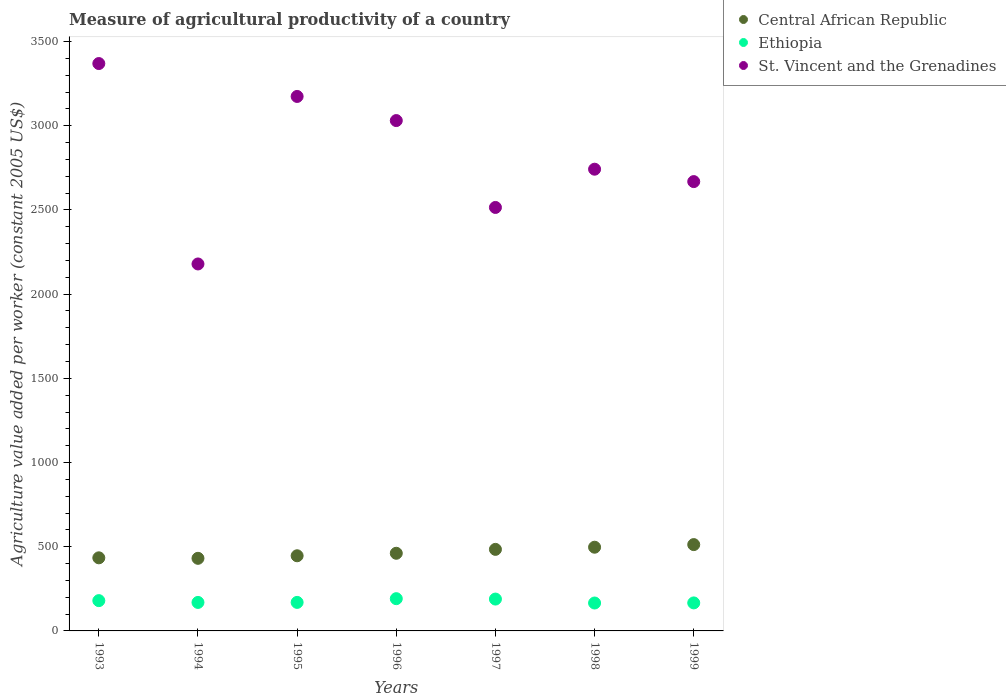What is the measure of agricultural productivity in Ethiopia in 1998?
Make the answer very short. 165.77. Across all years, what is the maximum measure of agricultural productivity in Ethiopia?
Offer a terse response. 191.52. Across all years, what is the minimum measure of agricultural productivity in Central African Republic?
Provide a succinct answer. 431.16. In which year was the measure of agricultural productivity in Ethiopia maximum?
Ensure brevity in your answer.  1996. What is the total measure of agricultural productivity in Central African Republic in the graph?
Provide a succinct answer. 3266.81. What is the difference between the measure of agricultural productivity in St. Vincent and the Grenadines in 1996 and that in 1998?
Offer a terse response. 288.8. What is the difference between the measure of agricultural productivity in Ethiopia in 1993 and the measure of agricultural productivity in St. Vincent and the Grenadines in 1995?
Keep it short and to the point. -2994.32. What is the average measure of agricultural productivity in Ethiopia per year?
Give a very brief answer. 175.9. In the year 1994, what is the difference between the measure of agricultural productivity in Ethiopia and measure of agricultural productivity in Central African Republic?
Keep it short and to the point. -261.98. What is the ratio of the measure of agricultural productivity in St. Vincent and the Grenadines in 1994 to that in 1997?
Your response must be concise. 0.87. What is the difference between the highest and the second highest measure of agricultural productivity in Central African Republic?
Your answer should be compact. 15.5. What is the difference between the highest and the lowest measure of agricultural productivity in St. Vincent and the Grenadines?
Give a very brief answer. 1190.19. Is it the case that in every year, the sum of the measure of agricultural productivity in St. Vincent and the Grenadines and measure of agricultural productivity in Ethiopia  is greater than the measure of agricultural productivity in Central African Republic?
Give a very brief answer. Yes. Is the measure of agricultural productivity in Central African Republic strictly less than the measure of agricultural productivity in St. Vincent and the Grenadines over the years?
Provide a succinct answer. Yes. How many dotlines are there?
Provide a succinct answer. 3. How many years are there in the graph?
Offer a very short reply. 7. What is the difference between two consecutive major ticks on the Y-axis?
Provide a succinct answer. 500. Are the values on the major ticks of Y-axis written in scientific E-notation?
Give a very brief answer. No. Does the graph contain grids?
Give a very brief answer. No. Where does the legend appear in the graph?
Provide a short and direct response. Top right. How are the legend labels stacked?
Your response must be concise. Vertical. What is the title of the graph?
Offer a terse response. Measure of agricultural productivity of a country. Does "Latin America(developing only)" appear as one of the legend labels in the graph?
Offer a very short reply. No. What is the label or title of the Y-axis?
Your response must be concise. Agriculture value added per worker (constant 2005 US$). What is the Agriculture value added per worker (constant 2005 US$) in Central African Republic in 1993?
Ensure brevity in your answer.  434.11. What is the Agriculture value added per worker (constant 2005 US$) in Ethiopia in 1993?
Provide a short and direct response. 179.89. What is the Agriculture value added per worker (constant 2005 US$) of St. Vincent and the Grenadines in 1993?
Your response must be concise. 3369.59. What is the Agriculture value added per worker (constant 2005 US$) in Central African Republic in 1994?
Your response must be concise. 431.16. What is the Agriculture value added per worker (constant 2005 US$) of Ethiopia in 1994?
Offer a terse response. 169.18. What is the Agriculture value added per worker (constant 2005 US$) of St. Vincent and the Grenadines in 1994?
Offer a terse response. 2179.39. What is the Agriculture value added per worker (constant 2005 US$) of Central African Republic in 1995?
Provide a succinct answer. 446.32. What is the Agriculture value added per worker (constant 2005 US$) in Ethiopia in 1995?
Provide a short and direct response. 169.39. What is the Agriculture value added per worker (constant 2005 US$) in St. Vincent and the Grenadines in 1995?
Offer a terse response. 3174.2. What is the Agriculture value added per worker (constant 2005 US$) in Central African Republic in 1996?
Your answer should be very brief. 461.15. What is the Agriculture value added per worker (constant 2005 US$) in Ethiopia in 1996?
Give a very brief answer. 191.52. What is the Agriculture value added per worker (constant 2005 US$) of St. Vincent and the Grenadines in 1996?
Make the answer very short. 3030.91. What is the Agriculture value added per worker (constant 2005 US$) of Central African Republic in 1997?
Your answer should be very brief. 484.31. What is the Agriculture value added per worker (constant 2005 US$) of Ethiopia in 1997?
Offer a terse response. 189.17. What is the Agriculture value added per worker (constant 2005 US$) of St. Vincent and the Grenadines in 1997?
Make the answer very short. 2514.94. What is the Agriculture value added per worker (constant 2005 US$) in Central African Republic in 1998?
Your answer should be very brief. 497.13. What is the Agriculture value added per worker (constant 2005 US$) in Ethiopia in 1998?
Ensure brevity in your answer.  165.77. What is the Agriculture value added per worker (constant 2005 US$) of St. Vincent and the Grenadines in 1998?
Provide a succinct answer. 2742.11. What is the Agriculture value added per worker (constant 2005 US$) of Central African Republic in 1999?
Provide a succinct answer. 512.63. What is the Agriculture value added per worker (constant 2005 US$) in Ethiopia in 1999?
Give a very brief answer. 166.37. What is the Agriculture value added per worker (constant 2005 US$) in St. Vincent and the Grenadines in 1999?
Provide a succinct answer. 2668.51. Across all years, what is the maximum Agriculture value added per worker (constant 2005 US$) in Central African Republic?
Provide a succinct answer. 512.63. Across all years, what is the maximum Agriculture value added per worker (constant 2005 US$) in Ethiopia?
Provide a short and direct response. 191.52. Across all years, what is the maximum Agriculture value added per worker (constant 2005 US$) of St. Vincent and the Grenadines?
Keep it short and to the point. 3369.59. Across all years, what is the minimum Agriculture value added per worker (constant 2005 US$) of Central African Republic?
Offer a terse response. 431.16. Across all years, what is the minimum Agriculture value added per worker (constant 2005 US$) of Ethiopia?
Your response must be concise. 165.77. Across all years, what is the minimum Agriculture value added per worker (constant 2005 US$) in St. Vincent and the Grenadines?
Give a very brief answer. 2179.39. What is the total Agriculture value added per worker (constant 2005 US$) in Central African Republic in the graph?
Provide a short and direct response. 3266.81. What is the total Agriculture value added per worker (constant 2005 US$) in Ethiopia in the graph?
Provide a short and direct response. 1231.28. What is the total Agriculture value added per worker (constant 2005 US$) in St. Vincent and the Grenadines in the graph?
Keep it short and to the point. 1.97e+04. What is the difference between the Agriculture value added per worker (constant 2005 US$) in Central African Republic in 1993 and that in 1994?
Your answer should be compact. 2.95. What is the difference between the Agriculture value added per worker (constant 2005 US$) of Ethiopia in 1993 and that in 1994?
Make the answer very short. 10.7. What is the difference between the Agriculture value added per worker (constant 2005 US$) of St. Vincent and the Grenadines in 1993 and that in 1994?
Provide a succinct answer. 1190.19. What is the difference between the Agriculture value added per worker (constant 2005 US$) in Central African Republic in 1993 and that in 1995?
Keep it short and to the point. -12.2. What is the difference between the Agriculture value added per worker (constant 2005 US$) of Ethiopia in 1993 and that in 1995?
Ensure brevity in your answer.  10.5. What is the difference between the Agriculture value added per worker (constant 2005 US$) in St. Vincent and the Grenadines in 1993 and that in 1995?
Your answer should be very brief. 195.38. What is the difference between the Agriculture value added per worker (constant 2005 US$) of Central African Republic in 1993 and that in 1996?
Keep it short and to the point. -27.04. What is the difference between the Agriculture value added per worker (constant 2005 US$) in Ethiopia in 1993 and that in 1996?
Your answer should be very brief. -11.64. What is the difference between the Agriculture value added per worker (constant 2005 US$) in St. Vincent and the Grenadines in 1993 and that in 1996?
Offer a very short reply. 338.68. What is the difference between the Agriculture value added per worker (constant 2005 US$) in Central African Republic in 1993 and that in 1997?
Your response must be concise. -50.19. What is the difference between the Agriculture value added per worker (constant 2005 US$) of Ethiopia in 1993 and that in 1997?
Your answer should be compact. -9.29. What is the difference between the Agriculture value added per worker (constant 2005 US$) of St. Vincent and the Grenadines in 1993 and that in 1997?
Give a very brief answer. 854.64. What is the difference between the Agriculture value added per worker (constant 2005 US$) in Central African Republic in 1993 and that in 1998?
Provide a succinct answer. -63.01. What is the difference between the Agriculture value added per worker (constant 2005 US$) of Ethiopia in 1993 and that in 1998?
Ensure brevity in your answer.  14.12. What is the difference between the Agriculture value added per worker (constant 2005 US$) in St. Vincent and the Grenadines in 1993 and that in 1998?
Ensure brevity in your answer.  627.48. What is the difference between the Agriculture value added per worker (constant 2005 US$) of Central African Republic in 1993 and that in 1999?
Offer a very short reply. -78.52. What is the difference between the Agriculture value added per worker (constant 2005 US$) of Ethiopia in 1993 and that in 1999?
Make the answer very short. 13.52. What is the difference between the Agriculture value added per worker (constant 2005 US$) of St. Vincent and the Grenadines in 1993 and that in 1999?
Keep it short and to the point. 701.08. What is the difference between the Agriculture value added per worker (constant 2005 US$) of Central African Republic in 1994 and that in 1995?
Make the answer very short. -15.15. What is the difference between the Agriculture value added per worker (constant 2005 US$) in Ethiopia in 1994 and that in 1995?
Your answer should be compact. -0.21. What is the difference between the Agriculture value added per worker (constant 2005 US$) of St. Vincent and the Grenadines in 1994 and that in 1995?
Your answer should be very brief. -994.81. What is the difference between the Agriculture value added per worker (constant 2005 US$) of Central African Republic in 1994 and that in 1996?
Your answer should be very brief. -29.99. What is the difference between the Agriculture value added per worker (constant 2005 US$) in Ethiopia in 1994 and that in 1996?
Provide a short and direct response. -22.34. What is the difference between the Agriculture value added per worker (constant 2005 US$) of St. Vincent and the Grenadines in 1994 and that in 1996?
Provide a short and direct response. -851.51. What is the difference between the Agriculture value added per worker (constant 2005 US$) in Central African Republic in 1994 and that in 1997?
Give a very brief answer. -53.15. What is the difference between the Agriculture value added per worker (constant 2005 US$) in Ethiopia in 1994 and that in 1997?
Your response must be concise. -19.99. What is the difference between the Agriculture value added per worker (constant 2005 US$) in St. Vincent and the Grenadines in 1994 and that in 1997?
Provide a succinct answer. -335.55. What is the difference between the Agriculture value added per worker (constant 2005 US$) in Central African Republic in 1994 and that in 1998?
Your response must be concise. -65.96. What is the difference between the Agriculture value added per worker (constant 2005 US$) in Ethiopia in 1994 and that in 1998?
Your response must be concise. 3.42. What is the difference between the Agriculture value added per worker (constant 2005 US$) in St. Vincent and the Grenadines in 1994 and that in 1998?
Your answer should be compact. -562.72. What is the difference between the Agriculture value added per worker (constant 2005 US$) in Central African Republic in 1994 and that in 1999?
Your response must be concise. -81.47. What is the difference between the Agriculture value added per worker (constant 2005 US$) in Ethiopia in 1994 and that in 1999?
Give a very brief answer. 2.82. What is the difference between the Agriculture value added per worker (constant 2005 US$) of St. Vincent and the Grenadines in 1994 and that in 1999?
Provide a succinct answer. -489.12. What is the difference between the Agriculture value added per worker (constant 2005 US$) of Central African Republic in 1995 and that in 1996?
Your answer should be very brief. -14.84. What is the difference between the Agriculture value added per worker (constant 2005 US$) in Ethiopia in 1995 and that in 1996?
Your answer should be compact. -22.13. What is the difference between the Agriculture value added per worker (constant 2005 US$) in St. Vincent and the Grenadines in 1995 and that in 1996?
Offer a terse response. 143.3. What is the difference between the Agriculture value added per worker (constant 2005 US$) in Central African Republic in 1995 and that in 1997?
Offer a very short reply. -37.99. What is the difference between the Agriculture value added per worker (constant 2005 US$) of Ethiopia in 1995 and that in 1997?
Your answer should be compact. -19.79. What is the difference between the Agriculture value added per worker (constant 2005 US$) of St. Vincent and the Grenadines in 1995 and that in 1997?
Offer a very short reply. 659.26. What is the difference between the Agriculture value added per worker (constant 2005 US$) in Central African Republic in 1995 and that in 1998?
Provide a short and direct response. -50.81. What is the difference between the Agriculture value added per worker (constant 2005 US$) in Ethiopia in 1995 and that in 1998?
Make the answer very short. 3.62. What is the difference between the Agriculture value added per worker (constant 2005 US$) in St. Vincent and the Grenadines in 1995 and that in 1998?
Your response must be concise. 432.09. What is the difference between the Agriculture value added per worker (constant 2005 US$) of Central African Republic in 1995 and that in 1999?
Give a very brief answer. -66.31. What is the difference between the Agriculture value added per worker (constant 2005 US$) of Ethiopia in 1995 and that in 1999?
Ensure brevity in your answer.  3.02. What is the difference between the Agriculture value added per worker (constant 2005 US$) in St. Vincent and the Grenadines in 1995 and that in 1999?
Provide a short and direct response. 505.69. What is the difference between the Agriculture value added per worker (constant 2005 US$) in Central African Republic in 1996 and that in 1997?
Offer a terse response. -23.15. What is the difference between the Agriculture value added per worker (constant 2005 US$) of Ethiopia in 1996 and that in 1997?
Your response must be concise. 2.35. What is the difference between the Agriculture value added per worker (constant 2005 US$) in St. Vincent and the Grenadines in 1996 and that in 1997?
Give a very brief answer. 515.96. What is the difference between the Agriculture value added per worker (constant 2005 US$) of Central African Republic in 1996 and that in 1998?
Offer a terse response. -35.97. What is the difference between the Agriculture value added per worker (constant 2005 US$) in Ethiopia in 1996 and that in 1998?
Offer a terse response. 25.76. What is the difference between the Agriculture value added per worker (constant 2005 US$) in St. Vincent and the Grenadines in 1996 and that in 1998?
Give a very brief answer. 288.8. What is the difference between the Agriculture value added per worker (constant 2005 US$) in Central African Republic in 1996 and that in 1999?
Provide a succinct answer. -51.47. What is the difference between the Agriculture value added per worker (constant 2005 US$) of Ethiopia in 1996 and that in 1999?
Provide a succinct answer. 25.16. What is the difference between the Agriculture value added per worker (constant 2005 US$) in St. Vincent and the Grenadines in 1996 and that in 1999?
Provide a short and direct response. 362.4. What is the difference between the Agriculture value added per worker (constant 2005 US$) in Central African Republic in 1997 and that in 1998?
Your answer should be very brief. -12.82. What is the difference between the Agriculture value added per worker (constant 2005 US$) of Ethiopia in 1997 and that in 1998?
Your answer should be very brief. 23.41. What is the difference between the Agriculture value added per worker (constant 2005 US$) in St. Vincent and the Grenadines in 1997 and that in 1998?
Provide a succinct answer. -227.17. What is the difference between the Agriculture value added per worker (constant 2005 US$) of Central African Republic in 1997 and that in 1999?
Give a very brief answer. -28.32. What is the difference between the Agriculture value added per worker (constant 2005 US$) of Ethiopia in 1997 and that in 1999?
Keep it short and to the point. 22.81. What is the difference between the Agriculture value added per worker (constant 2005 US$) of St. Vincent and the Grenadines in 1997 and that in 1999?
Offer a very short reply. -153.57. What is the difference between the Agriculture value added per worker (constant 2005 US$) in Central African Republic in 1998 and that in 1999?
Offer a very short reply. -15.5. What is the difference between the Agriculture value added per worker (constant 2005 US$) in Ethiopia in 1998 and that in 1999?
Give a very brief answer. -0.6. What is the difference between the Agriculture value added per worker (constant 2005 US$) of St. Vincent and the Grenadines in 1998 and that in 1999?
Your response must be concise. 73.6. What is the difference between the Agriculture value added per worker (constant 2005 US$) of Central African Republic in 1993 and the Agriculture value added per worker (constant 2005 US$) of Ethiopia in 1994?
Offer a very short reply. 264.93. What is the difference between the Agriculture value added per worker (constant 2005 US$) of Central African Republic in 1993 and the Agriculture value added per worker (constant 2005 US$) of St. Vincent and the Grenadines in 1994?
Make the answer very short. -1745.28. What is the difference between the Agriculture value added per worker (constant 2005 US$) of Ethiopia in 1993 and the Agriculture value added per worker (constant 2005 US$) of St. Vincent and the Grenadines in 1994?
Provide a succinct answer. -1999.51. What is the difference between the Agriculture value added per worker (constant 2005 US$) in Central African Republic in 1993 and the Agriculture value added per worker (constant 2005 US$) in Ethiopia in 1995?
Give a very brief answer. 264.72. What is the difference between the Agriculture value added per worker (constant 2005 US$) in Central African Republic in 1993 and the Agriculture value added per worker (constant 2005 US$) in St. Vincent and the Grenadines in 1995?
Make the answer very short. -2740.09. What is the difference between the Agriculture value added per worker (constant 2005 US$) of Ethiopia in 1993 and the Agriculture value added per worker (constant 2005 US$) of St. Vincent and the Grenadines in 1995?
Ensure brevity in your answer.  -2994.32. What is the difference between the Agriculture value added per worker (constant 2005 US$) of Central African Republic in 1993 and the Agriculture value added per worker (constant 2005 US$) of Ethiopia in 1996?
Offer a terse response. 242.59. What is the difference between the Agriculture value added per worker (constant 2005 US$) in Central African Republic in 1993 and the Agriculture value added per worker (constant 2005 US$) in St. Vincent and the Grenadines in 1996?
Your answer should be very brief. -2596.79. What is the difference between the Agriculture value added per worker (constant 2005 US$) of Ethiopia in 1993 and the Agriculture value added per worker (constant 2005 US$) of St. Vincent and the Grenadines in 1996?
Keep it short and to the point. -2851.02. What is the difference between the Agriculture value added per worker (constant 2005 US$) of Central African Republic in 1993 and the Agriculture value added per worker (constant 2005 US$) of Ethiopia in 1997?
Make the answer very short. 244.94. What is the difference between the Agriculture value added per worker (constant 2005 US$) of Central African Republic in 1993 and the Agriculture value added per worker (constant 2005 US$) of St. Vincent and the Grenadines in 1997?
Provide a short and direct response. -2080.83. What is the difference between the Agriculture value added per worker (constant 2005 US$) of Ethiopia in 1993 and the Agriculture value added per worker (constant 2005 US$) of St. Vincent and the Grenadines in 1997?
Give a very brief answer. -2335.06. What is the difference between the Agriculture value added per worker (constant 2005 US$) in Central African Republic in 1993 and the Agriculture value added per worker (constant 2005 US$) in Ethiopia in 1998?
Offer a very short reply. 268.35. What is the difference between the Agriculture value added per worker (constant 2005 US$) of Central African Republic in 1993 and the Agriculture value added per worker (constant 2005 US$) of St. Vincent and the Grenadines in 1998?
Your answer should be very brief. -2308. What is the difference between the Agriculture value added per worker (constant 2005 US$) of Ethiopia in 1993 and the Agriculture value added per worker (constant 2005 US$) of St. Vincent and the Grenadines in 1998?
Offer a very short reply. -2562.22. What is the difference between the Agriculture value added per worker (constant 2005 US$) in Central African Republic in 1993 and the Agriculture value added per worker (constant 2005 US$) in Ethiopia in 1999?
Make the answer very short. 267.75. What is the difference between the Agriculture value added per worker (constant 2005 US$) of Central African Republic in 1993 and the Agriculture value added per worker (constant 2005 US$) of St. Vincent and the Grenadines in 1999?
Your answer should be very brief. -2234.4. What is the difference between the Agriculture value added per worker (constant 2005 US$) of Ethiopia in 1993 and the Agriculture value added per worker (constant 2005 US$) of St. Vincent and the Grenadines in 1999?
Provide a succinct answer. -2488.63. What is the difference between the Agriculture value added per worker (constant 2005 US$) of Central African Republic in 1994 and the Agriculture value added per worker (constant 2005 US$) of Ethiopia in 1995?
Your answer should be very brief. 261.77. What is the difference between the Agriculture value added per worker (constant 2005 US$) in Central African Republic in 1994 and the Agriculture value added per worker (constant 2005 US$) in St. Vincent and the Grenadines in 1995?
Provide a short and direct response. -2743.04. What is the difference between the Agriculture value added per worker (constant 2005 US$) of Ethiopia in 1994 and the Agriculture value added per worker (constant 2005 US$) of St. Vincent and the Grenadines in 1995?
Provide a succinct answer. -3005.02. What is the difference between the Agriculture value added per worker (constant 2005 US$) of Central African Republic in 1994 and the Agriculture value added per worker (constant 2005 US$) of Ethiopia in 1996?
Offer a very short reply. 239.64. What is the difference between the Agriculture value added per worker (constant 2005 US$) of Central African Republic in 1994 and the Agriculture value added per worker (constant 2005 US$) of St. Vincent and the Grenadines in 1996?
Make the answer very short. -2599.74. What is the difference between the Agriculture value added per worker (constant 2005 US$) of Ethiopia in 1994 and the Agriculture value added per worker (constant 2005 US$) of St. Vincent and the Grenadines in 1996?
Offer a very short reply. -2861.72. What is the difference between the Agriculture value added per worker (constant 2005 US$) in Central African Republic in 1994 and the Agriculture value added per worker (constant 2005 US$) in Ethiopia in 1997?
Your answer should be compact. 241.99. What is the difference between the Agriculture value added per worker (constant 2005 US$) in Central African Republic in 1994 and the Agriculture value added per worker (constant 2005 US$) in St. Vincent and the Grenadines in 1997?
Your response must be concise. -2083.78. What is the difference between the Agriculture value added per worker (constant 2005 US$) of Ethiopia in 1994 and the Agriculture value added per worker (constant 2005 US$) of St. Vincent and the Grenadines in 1997?
Provide a succinct answer. -2345.76. What is the difference between the Agriculture value added per worker (constant 2005 US$) of Central African Republic in 1994 and the Agriculture value added per worker (constant 2005 US$) of Ethiopia in 1998?
Give a very brief answer. 265.4. What is the difference between the Agriculture value added per worker (constant 2005 US$) of Central African Republic in 1994 and the Agriculture value added per worker (constant 2005 US$) of St. Vincent and the Grenadines in 1998?
Your answer should be very brief. -2310.95. What is the difference between the Agriculture value added per worker (constant 2005 US$) in Ethiopia in 1994 and the Agriculture value added per worker (constant 2005 US$) in St. Vincent and the Grenadines in 1998?
Offer a very short reply. -2572.93. What is the difference between the Agriculture value added per worker (constant 2005 US$) in Central African Republic in 1994 and the Agriculture value added per worker (constant 2005 US$) in Ethiopia in 1999?
Ensure brevity in your answer.  264.8. What is the difference between the Agriculture value added per worker (constant 2005 US$) of Central African Republic in 1994 and the Agriculture value added per worker (constant 2005 US$) of St. Vincent and the Grenadines in 1999?
Give a very brief answer. -2237.35. What is the difference between the Agriculture value added per worker (constant 2005 US$) in Ethiopia in 1994 and the Agriculture value added per worker (constant 2005 US$) in St. Vincent and the Grenadines in 1999?
Give a very brief answer. -2499.33. What is the difference between the Agriculture value added per worker (constant 2005 US$) in Central African Republic in 1995 and the Agriculture value added per worker (constant 2005 US$) in Ethiopia in 1996?
Give a very brief answer. 254.79. What is the difference between the Agriculture value added per worker (constant 2005 US$) of Central African Republic in 1995 and the Agriculture value added per worker (constant 2005 US$) of St. Vincent and the Grenadines in 1996?
Provide a short and direct response. -2584.59. What is the difference between the Agriculture value added per worker (constant 2005 US$) in Ethiopia in 1995 and the Agriculture value added per worker (constant 2005 US$) in St. Vincent and the Grenadines in 1996?
Make the answer very short. -2861.52. What is the difference between the Agriculture value added per worker (constant 2005 US$) in Central African Republic in 1995 and the Agriculture value added per worker (constant 2005 US$) in Ethiopia in 1997?
Offer a very short reply. 257.14. What is the difference between the Agriculture value added per worker (constant 2005 US$) in Central African Republic in 1995 and the Agriculture value added per worker (constant 2005 US$) in St. Vincent and the Grenadines in 1997?
Provide a short and direct response. -2068.63. What is the difference between the Agriculture value added per worker (constant 2005 US$) of Ethiopia in 1995 and the Agriculture value added per worker (constant 2005 US$) of St. Vincent and the Grenadines in 1997?
Make the answer very short. -2345.55. What is the difference between the Agriculture value added per worker (constant 2005 US$) of Central African Republic in 1995 and the Agriculture value added per worker (constant 2005 US$) of Ethiopia in 1998?
Make the answer very short. 280.55. What is the difference between the Agriculture value added per worker (constant 2005 US$) in Central African Republic in 1995 and the Agriculture value added per worker (constant 2005 US$) in St. Vincent and the Grenadines in 1998?
Keep it short and to the point. -2295.79. What is the difference between the Agriculture value added per worker (constant 2005 US$) in Ethiopia in 1995 and the Agriculture value added per worker (constant 2005 US$) in St. Vincent and the Grenadines in 1998?
Offer a terse response. -2572.72. What is the difference between the Agriculture value added per worker (constant 2005 US$) in Central African Republic in 1995 and the Agriculture value added per worker (constant 2005 US$) in Ethiopia in 1999?
Ensure brevity in your answer.  279.95. What is the difference between the Agriculture value added per worker (constant 2005 US$) of Central African Republic in 1995 and the Agriculture value added per worker (constant 2005 US$) of St. Vincent and the Grenadines in 1999?
Your answer should be very brief. -2222.2. What is the difference between the Agriculture value added per worker (constant 2005 US$) of Ethiopia in 1995 and the Agriculture value added per worker (constant 2005 US$) of St. Vincent and the Grenadines in 1999?
Offer a very short reply. -2499.12. What is the difference between the Agriculture value added per worker (constant 2005 US$) of Central African Republic in 1996 and the Agriculture value added per worker (constant 2005 US$) of Ethiopia in 1997?
Provide a succinct answer. 271.98. What is the difference between the Agriculture value added per worker (constant 2005 US$) of Central African Republic in 1996 and the Agriculture value added per worker (constant 2005 US$) of St. Vincent and the Grenadines in 1997?
Make the answer very short. -2053.79. What is the difference between the Agriculture value added per worker (constant 2005 US$) of Ethiopia in 1996 and the Agriculture value added per worker (constant 2005 US$) of St. Vincent and the Grenadines in 1997?
Provide a succinct answer. -2323.42. What is the difference between the Agriculture value added per worker (constant 2005 US$) in Central African Republic in 1996 and the Agriculture value added per worker (constant 2005 US$) in Ethiopia in 1998?
Offer a very short reply. 295.39. What is the difference between the Agriculture value added per worker (constant 2005 US$) in Central African Republic in 1996 and the Agriculture value added per worker (constant 2005 US$) in St. Vincent and the Grenadines in 1998?
Your answer should be compact. -2280.96. What is the difference between the Agriculture value added per worker (constant 2005 US$) of Ethiopia in 1996 and the Agriculture value added per worker (constant 2005 US$) of St. Vincent and the Grenadines in 1998?
Offer a very short reply. -2550.59. What is the difference between the Agriculture value added per worker (constant 2005 US$) in Central African Republic in 1996 and the Agriculture value added per worker (constant 2005 US$) in Ethiopia in 1999?
Keep it short and to the point. 294.79. What is the difference between the Agriculture value added per worker (constant 2005 US$) in Central African Republic in 1996 and the Agriculture value added per worker (constant 2005 US$) in St. Vincent and the Grenadines in 1999?
Keep it short and to the point. -2207.36. What is the difference between the Agriculture value added per worker (constant 2005 US$) in Ethiopia in 1996 and the Agriculture value added per worker (constant 2005 US$) in St. Vincent and the Grenadines in 1999?
Make the answer very short. -2476.99. What is the difference between the Agriculture value added per worker (constant 2005 US$) of Central African Republic in 1997 and the Agriculture value added per worker (constant 2005 US$) of Ethiopia in 1998?
Offer a terse response. 318.54. What is the difference between the Agriculture value added per worker (constant 2005 US$) of Central African Republic in 1997 and the Agriculture value added per worker (constant 2005 US$) of St. Vincent and the Grenadines in 1998?
Provide a succinct answer. -2257.8. What is the difference between the Agriculture value added per worker (constant 2005 US$) in Ethiopia in 1997 and the Agriculture value added per worker (constant 2005 US$) in St. Vincent and the Grenadines in 1998?
Make the answer very short. -2552.94. What is the difference between the Agriculture value added per worker (constant 2005 US$) in Central African Republic in 1997 and the Agriculture value added per worker (constant 2005 US$) in Ethiopia in 1999?
Keep it short and to the point. 317.94. What is the difference between the Agriculture value added per worker (constant 2005 US$) in Central African Republic in 1997 and the Agriculture value added per worker (constant 2005 US$) in St. Vincent and the Grenadines in 1999?
Give a very brief answer. -2184.2. What is the difference between the Agriculture value added per worker (constant 2005 US$) of Ethiopia in 1997 and the Agriculture value added per worker (constant 2005 US$) of St. Vincent and the Grenadines in 1999?
Your answer should be very brief. -2479.34. What is the difference between the Agriculture value added per worker (constant 2005 US$) of Central African Republic in 1998 and the Agriculture value added per worker (constant 2005 US$) of Ethiopia in 1999?
Your answer should be very brief. 330.76. What is the difference between the Agriculture value added per worker (constant 2005 US$) in Central African Republic in 1998 and the Agriculture value added per worker (constant 2005 US$) in St. Vincent and the Grenadines in 1999?
Make the answer very short. -2171.39. What is the difference between the Agriculture value added per worker (constant 2005 US$) of Ethiopia in 1998 and the Agriculture value added per worker (constant 2005 US$) of St. Vincent and the Grenadines in 1999?
Provide a short and direct response. -2502.74. What is the average Agriculture value added per worker (constant 2005 US$) in Central African Republic per year?
Offer a terse response. 466.69. What is the average Agriculture value added per worker (constant 2005 US$) of Ethiopia per year?
Your response must be concise. 175.9. What is the average Agriculture value added per worker (constant 2005 US$) in St. Vincent and the Grenadines per year?
Provide a succinct answer. 2811.38. In the year 1993, what is the difference between the Agriculture value added per worker (constant 2005 US$) in Central African Republic and Agriculture value added per worker (constant 2005 US$) in Ethiopia?
Keep it short and to the point. 254.23. In the year 1993, what is the difference between the Agriculture value added per worker (constant 2005 US$) of Central African Republic and Agriculture value added per worker (constant 2005 US$) of St. Vincent and the Grenadines?
Ensure brevity in your answer.  -2935.47. In the year 1993, what is the difference between the Agriculture value added per worker (constant 2005 US$) of Ethiopia and Agriculture value added per worker (constant 2005 US$) of St. Vincent and the Grenadines?
Your response must be concise. -3189.7. In the year 1994, what is the difference between the Agriculture value added per worker (constant 2005 US$) in Central African Republic and Agriculture value added per worker (constant 2005 US$) in Ethiopia?
Your response must be concise. 261.98. In the year 1994, what is the difference between the Agriculture value added per worker (constant 2005 US$) in Central African Republic and Agriculture value added per worker (constant 2005 US$) in St. Vincent and the Grenadines?
Your answer should be very brief. -1748.23. In the year 1994, what is the difference between the Agriculture value added per worker (constant 2005 US$) in Ethiopia and Agriculture value added per worker (constant 2005 US$) in St. Vincent and the Grenadines?
Your answer should be very brief. -2010.21. In the year 1995, what is the difference between the Agriculture value added per worker (constant 2005 US$) of Central African Republic and Agriculture value added per worker (constant 2005 US$) of Ethiopia?
Your answer should be compact. 276.93. In the year 1995, what is the difference between the Agriculture value added per worker (constant 2005 US$) of Central African Republic and Agriculture value added per worker (constant 2005 US$) of St. Vincent and the Grenadines?
Give a very brief answer. -2727.89. In the year 1995, what is the difference between the Agriculture value added per worker (constant 2005 US$) of Ethiopia and Agriculture value added per worker (constant 2005 US$) of St. Vincent and the Grenadines?
Make the answer very short. -3004.81. In the year 1996, what is the difference between the Agriculture value added per worker (constant 2005 US$) of Central African Republic and Agriculture value added per worker (constant 2005 US$) of Ethiopia?
Provide a short and direct response. 269.63. In the year 1996, what is the difference between the Agriculture value added per worker (constant 2005 US$) of Central African Republic and Agriculture value added per worker (constant 2005 US$) of St. Vincent and the Grenadines?
Ensure brevity in your answer.  -2569.75. In the year 1996, what is the difference between the Agriculture value added per worker (constant 2005 US$) in Ethiopia and Agriculture value added per worker (constant 2005 US$) in St. Vincent and the Grenadines?
Provide a short and direct response. -2839.38. In the year 1997, what is the difference between the Agriculture value added per worker (constant 2005 US$) in Central African Republic and Agriculture value added per worker (constant 2005 US$) in Ethiopia?
Keep it short and to the point. 295.13. In the year 1997, what is the difference between the Agriculture value added per worker (constant 2005 US$) in Central African Republic and Agriculture value added per worker (constant 2005 US$) in St. Vincent and the Grenadines?
Your answer should be very brief. -2030.64. In the year 1997, what is the difference between the Agriculture value added per worker (constant 2005 US$) of Ethiopia and Agriculture value added per worker (constant 2005 US$) of St. Vincent and the Grenadines?
Keep it short and to the point. -2325.77. In the year 1998, what is the difference between the Agriculture value added per worker (constant 2005 US$) of Central African Republic and Agriculture value added per worker (constant 2005 US$) of Ethiopia?
Offer a very short reply. 331.36. In the year 1998, what is the difference between the Agriculture value added per worker (constant 2005 US$) in Central African Republic and Agriculture value added per worker (constant 2005 US$) in St. Vincent and the Grenadines?
Provide a succinct answer. -2244.98. In the year 1998, what is the difference between the Agriculture value added per worker (constant 2005 US$) in Ethiopia and Agriculture value added per worker (constant 2005 US$) in St. Vincent and the Grenadines?
Offer a terse response. -2576.34. In the year 1999, what is the difference between the Agriculture value added per worker (constant 2005 US$) in Central African Republic and Agriculture value added per worker (constant 2005 US$) in Ethiopia?
Keep it short and to the point. 346.26. In the year 1999, what is the difference between the Agriculture value added per worker (constant 2005 US$) of Central African Republic and Agriculture value added per worker (constant 2005 US$) of St. Vincent and the Grenadines?
Your answer should be compact. -2155.88. In the year 1999, what is the difference between the Agriculture value added per worker (constant 2005 US$) in Ethiopia and Agriculture value added per worker (constant 2005 US$) in St. Vincent and the Grenadines?
Provide a succinct answer. -2502.15. What is the ratio of the Agriculture value added per worker (constant 2005 US$) of Central African Republic in 1993 to that in 1994?
Your response must be concise. 1.01. What is the ratio of the Agriculture value added per worker (constant 2005 US$) of Ethiopia in 1993 to that in 1994?
Keep it short and to the point. 1.06. What is the ratio of the Agriculture value added per worker (constant 2005 US$) of St. Vincent and the Grenadines in 1993 to that in 1994?
Your response must be concise. 1.55. What is the ratio of the Agriculture value added per worker (constant 2005 US$) in Central African Republic in 1993 to that in 1995?
Make the answer very short. 0.97. What is the ratio of the Agriculture value added per worker (constant 2005 US$) of Ethiopia in 1993 to that in 1995?
Ensure brevity in your answer.  1.06. What is the ratio of the Agriculture value added per worker (constant 2005 US$) of St. Vincent and the Grenadines in 1993 to that in 1995?
Your response must be concise. 1.06. What is the ratio of the Agriculture value added per worker (constant 2005 US$) in Central African Republic in 1993 to that in 1996?
Your answer should be very brief. 0.94. What is the ratio of the Agriculture value added per worker (constant 2005 US$) in Ethiopia in 1993 to that in 1996?
Provide a succinct answer. 0.94. What is the ratio of the Agriculture value added per worker (constant 2005 US$) of St. Vincent and the Grenadines in 1993 to that in 1996?
Keep it short and to the point. 1.11. What is the ratio of the Agriculture value added per worker (constant 2005 US$) of Central African Republic in 1993 to that in 1997?
Provide a short and direct response. 0.9. What is the ratio of the Agriculture value added per worker (constant 2005 US$) in Ethiopia in 1993 to that in 1997?
Keep it short and to the point. 0.95. What is the ratio of the Agriculture value added per worker (constant 2005 US$) in St. Vincent and the Grenadines in 1993 to that in 1997?
Offer a very short reply. 1.34. What is the ratio of the Agriculture value added per worker (constant 2005 US$) in Central African Republic in 1993 to that in 1998?
Give a very brief answer. 0.87. What is the ratio of the Agriculture value added per worker (constant 2005 US$) in Ethiopia in 1993 to that in 1998?
Give a very brief answer. 1.09. What is the ratio of the Agriculture value added per worker (constant 2005 US$) in St. Vincent and the Grenadines in 1993 to that in 1998?
Offer a terse response. 1.23. What is the ratio of the Agriculture value added per worker (constant 2005 US$) in Central African Republic in 1993 to that in 1999?
Ensure brevity in your answer.  0.85. What is the ratio of the Agriculture value added per worker (constant 2005 US$) of Ethiopia in 1993 to that in 1999?
Your answer should be compact. 1.08. What is the ratio of the Agriculture value added per worker (constant 2005 US$) of St. Vincent and the Grenadines in 1993 to that in 1999?
Your response must be concise. 1.26. What is the ratio of the Agriculture value added per worker (constant 2005 US$) in Ethiopia in 1994 to that in 1995?
Offer a very short reply. 1. What is the ratio of the Agriculture value added per worker (constant 2005 US$) in St. Vincent and the Grenadines in 1994 to that in 1995?
Provide a succinct answer. 0.69. What is the ratio of the Agriculture value added per worker (constant 2005 US$) in Central African Republic in 1994 to that in 1996?
Your answer should be very brief. 0.94. What is the ratio of the Agriculture value added per worker (constant 2005 US$) of Ethiopia in 1994 to that in 1996?
Offer a very short reply. 0.88. What is the ratio of the Agriculture value added per worker (constant 2005 US$) in St. Vincent and the Grenadines in 1994 to that in 1996?
Your response must be concise. 0.72. What is the ratio of the Agriculture value added per worker (constant 2005 US$) in Central African Republic in 1994 to that in 1997?
Provide a succinct answer. 0.89. What is the ratio of the Agriculture value added per worker (constant 2005 US$) of Ethiopia in 1994 to that in 1997?
Offer a terse response. 0.89. What is the ratio of the Agriculture value added per worker (constant 2005 US$) in St. Vincent and the Grenadines in 1994 to that in 1997?
Provide a short and direct response. 0.87. What is the ratio of the Agriculture value added per worker (constant 2005 US$) in Central African Republic in 1994 to that in 1998?
Offer a terse response. 0.87. What is the ratio of the Agriculture value added per worker (constant 2005 US$) of Ethiopia in 1994 to that in 1998?
Offer a very short reply. 1.02. What is the ratio of the Agriculture value added per worker (constant 2005 US$) in St. Vincent and the Grenadines in 1994 to that in 1998?
Provide a succinct answer. 0.79. What is the ratio of the Agriculture value added per worker (constant 2005 US$) in Central African Republic in 1994 to that in 1999?
Your answer should be very brief. 0.84. What is the ratio of the Agriculture value added per worker (constant 2005 US$) of Ethiopia in 1994 to that in 1999?
Your answer should be compact. 1.02. What is the ratio of the Agriculture value added per worker (constant 2005 US$) in St. Vincent and the Grenadines in 1994 to that in 1999?
Give a very brief answer. 0.82. What is the ratio of the Agriculture value added per worker (constant 2005 US$) in Central African Republic in 1995 to that in 1996?
Your answer should be very brief. 0.97. What is the ratio of the Agriculture value added per worker (constant 2005 US$) of Ethiopia in 1995 to that in 1996?
Your answer should be compact. 0.88. What is the ratio of the Agriculture value added per worker (constant 2005 US$) in St. Vincent and the Grenadines in 1995 to that in 1996?
Offer a very short reply. 1.05. What is the ratio of the Agriculture value added per worker (constant 2005 US$) of Central African Republic in 1995 to that in 1997?
Provide a short and direct response. 0.92. What is the ratio of the Agriculture value added per worker (constant 2005 US$) of Ethiopia in 1995 to that in 1997?
Your response must be concise. 0.9. What is the ratio of the Agriculture value added per worker (constant 2005 US$) of St. Vincent and the Grenadines in 1995 to that in 1997?
Give a very brief answer. 1.26. What is the ratio of the Agriculture value added per worker (constant 2005 US$) of Central African Republic in 1995 to that in 1998?
Provide a succinct answer. 0.9. What is the ratio of the Agriculture value added per worker (constant 2005 US$) in Ethiopia in 1995 to that in 1998?
Provide a succinct answer. 1.02. What is the ratio of the Agriculture value added per worker (constant 2005 US$) in St. Vincent and the Grenadines in 1995 to that in 1998?
Your response must be concise. 1.16. What is the ratio of the Agriculture value added per worker (constant 2005 US$) in Central African Republic in 1995 to that in 1999?
Offer a terse response. 0.87. What is the ratio of the Agriculture value added per worker (constant 2005 US$) in Ethiopia in 1995 to that in 1999?
Keep it short and to the point. 1.02. What is the ratio of the Agriculture value added per worker (constant 2005 US$) in St. Vincent and the Grenadines in 1995 to that in 1999?
Offer a terse response. 1.19. What is the ratio of the Agriculture value added per worker (constant 2005 US$) of Central African Republic in 1996 to that in 1997?
Offer a terse response. 0.95. What is the ratio of the Agriculture value added per worker (constant 2005 US$) in Ethiopia in 1996 to that in 1997?
Keep it short and to the point. 1.01. What is the ratio of the Agriculture value added per worker (constant 2005 US$) of St. Vincent and the Grenadines in 1996 to that in 1997?
Make the answer very short. 1.21. What is the ratio of the Agriculture value added per worker (constant 2005 US$) in Central African Republic in 1996 to that in 1998?
Provide a succinct answer. 0.93. What is the ratio of the Agriculture value added per worker (constant 2005 US$) of Ethiopia in 1996 to that in 1998?
Give a very brief answer. 1.16. What is the ratio of the Agriculture value added per worker (constant 2005 US$) of St. Vincent and the Grenadines in 1996 to that in 1998?
Offer a very short reply. 1.11. What is the ratio of the Agriculture value added per worker (constant 2005 US$) in Central African Republic in 1996 to that in 1999?
Your answer should be very brief. 0.9. What is the ratio of the Agriculture value added per worker (constant 2005 US$) of Ethiopia in 1996 to that in 1999?
Give a very brief answer. 1.15. What is the ratio of the Agriculture value added per worker (constant 2005 US$) of St. Vincent and the Grenadines in 1996 to that in 1999?
Your answer should be very brief. 1.14. What is the ratio of the Agriculture value added per worker (constant 2005 US$) in Central African Republic in 1997 to that in 1998?
Keep it short and to the point. 0.97. What is the ratio of the Agriculture value added per worker (constant 2005 US$) in Ethiopia in 1997 to that in 1998?
Provide a short and direct response. 1.14. What is the ratio of the Agriculture value added per worker (constant 2005 US$) of St. Vincent and the Grenadines in 1997 to that in 1998?
Your answer should be very brief. 0.92. What is the ratio of the Agriculture value added per worker (constant 2005 US$) of Central African Republic in 1997 to that in 1999?
Your answer should be compact. 0.94. What is the ratio of the Agriculture value added per worker (constant 2005 US$) of Ethiopia in 1997 to that in 1999?
Your answer should be compact. 1.14. What is the ratio of the Agriculture value added per worker (constant 2005 US$) of St. Vincent and the Grenadines in 1997 to that in 1999?
Your answer should be very brief. 0.94. What is the ratio of the Agriculture value added per worker (constant 2005 US$) in Central African Republic in 1998 to that in 1999?
Ensure brevity in your answer.  0.97. What is the ratio of the Agriculture value added per worker (constant 2005 US$) of St. Vincent and the Grenadines in 1998 to that in 1999?
Your answer should be compact. 1.03. What is the difference between the highest and the second highest Agriculture value added per worker (constant 2005 US$) in Central African Republic?
Offer a very short reply. 15.5. What is the difference between the highest and the second highest Agriculture value added per worker (constant 2005 US$) of Ethiopia?
Ensure brevity in your answer.  2.35. What is the difference between the highest and the second highest Agriculture value added per worker (constant 2005 US$) of St. Vincent and the Grenadines?
Ensure brevity in your answer.  195.38. What is the difference between the highest and the lowest Agriculture value added per worker (constant 2005 US$) of Central African Republic?
Offer a terse response. 81.47. What is the difference between the highest and the lowest Agriculture value added per worker (constant 2005 US$) in Ethiopia?
Offer a very short reply. 25.76. What is the difference between the highest and the lowest Agriculture value added per worker (constant 2005 US$) in St. Vincent and the Grenadines?
Make the answer very short. 1190.19. 